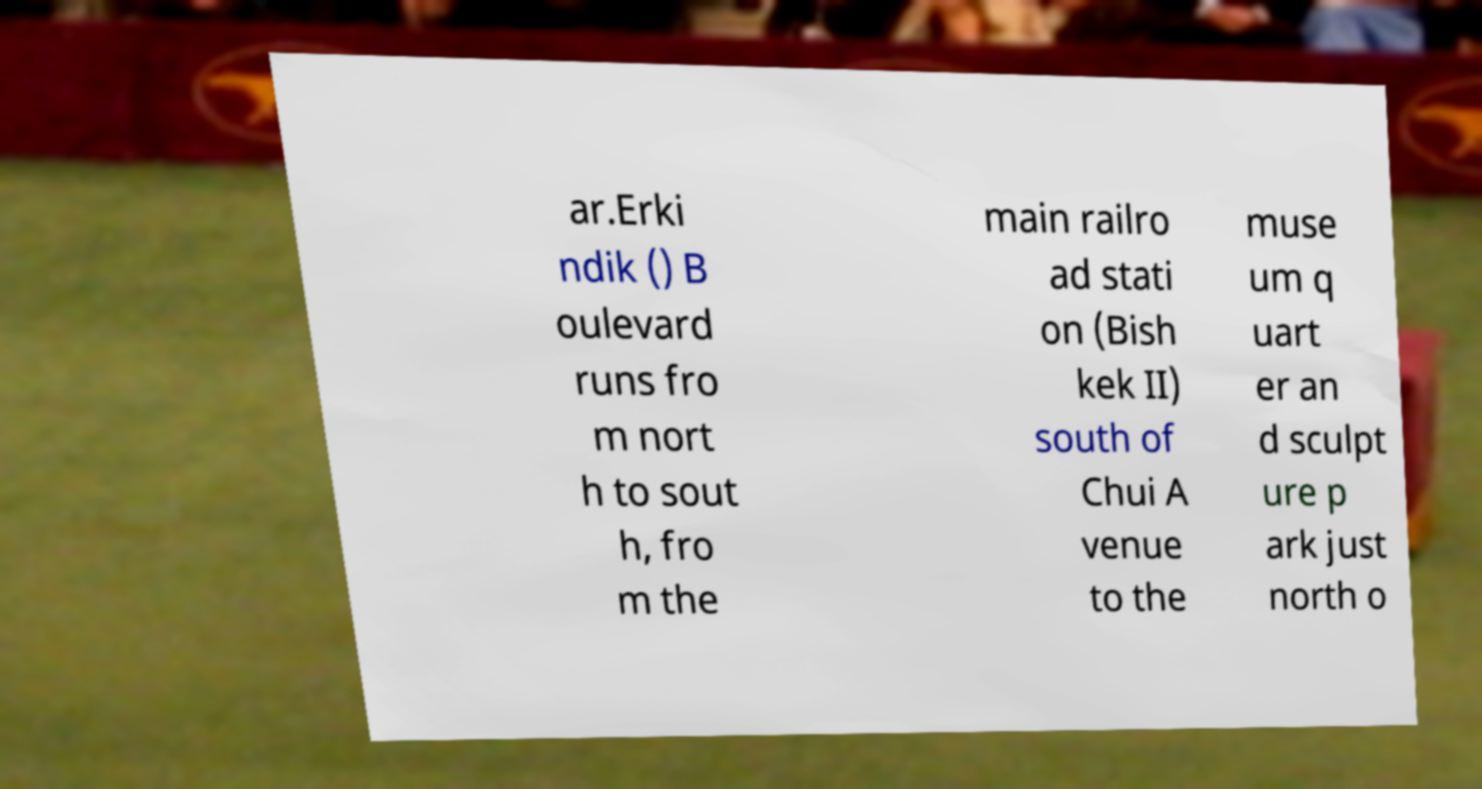For documentation purposes, I need the text within this image transcribed. Could you provide that? ar.Erki ndik () B oulevard runs fro m nort h to sout h, fro m the main railro ad stati on (Bish kek II) south of Chui A venue to the muse um q uart er an d sculpt ure p ark just north o 